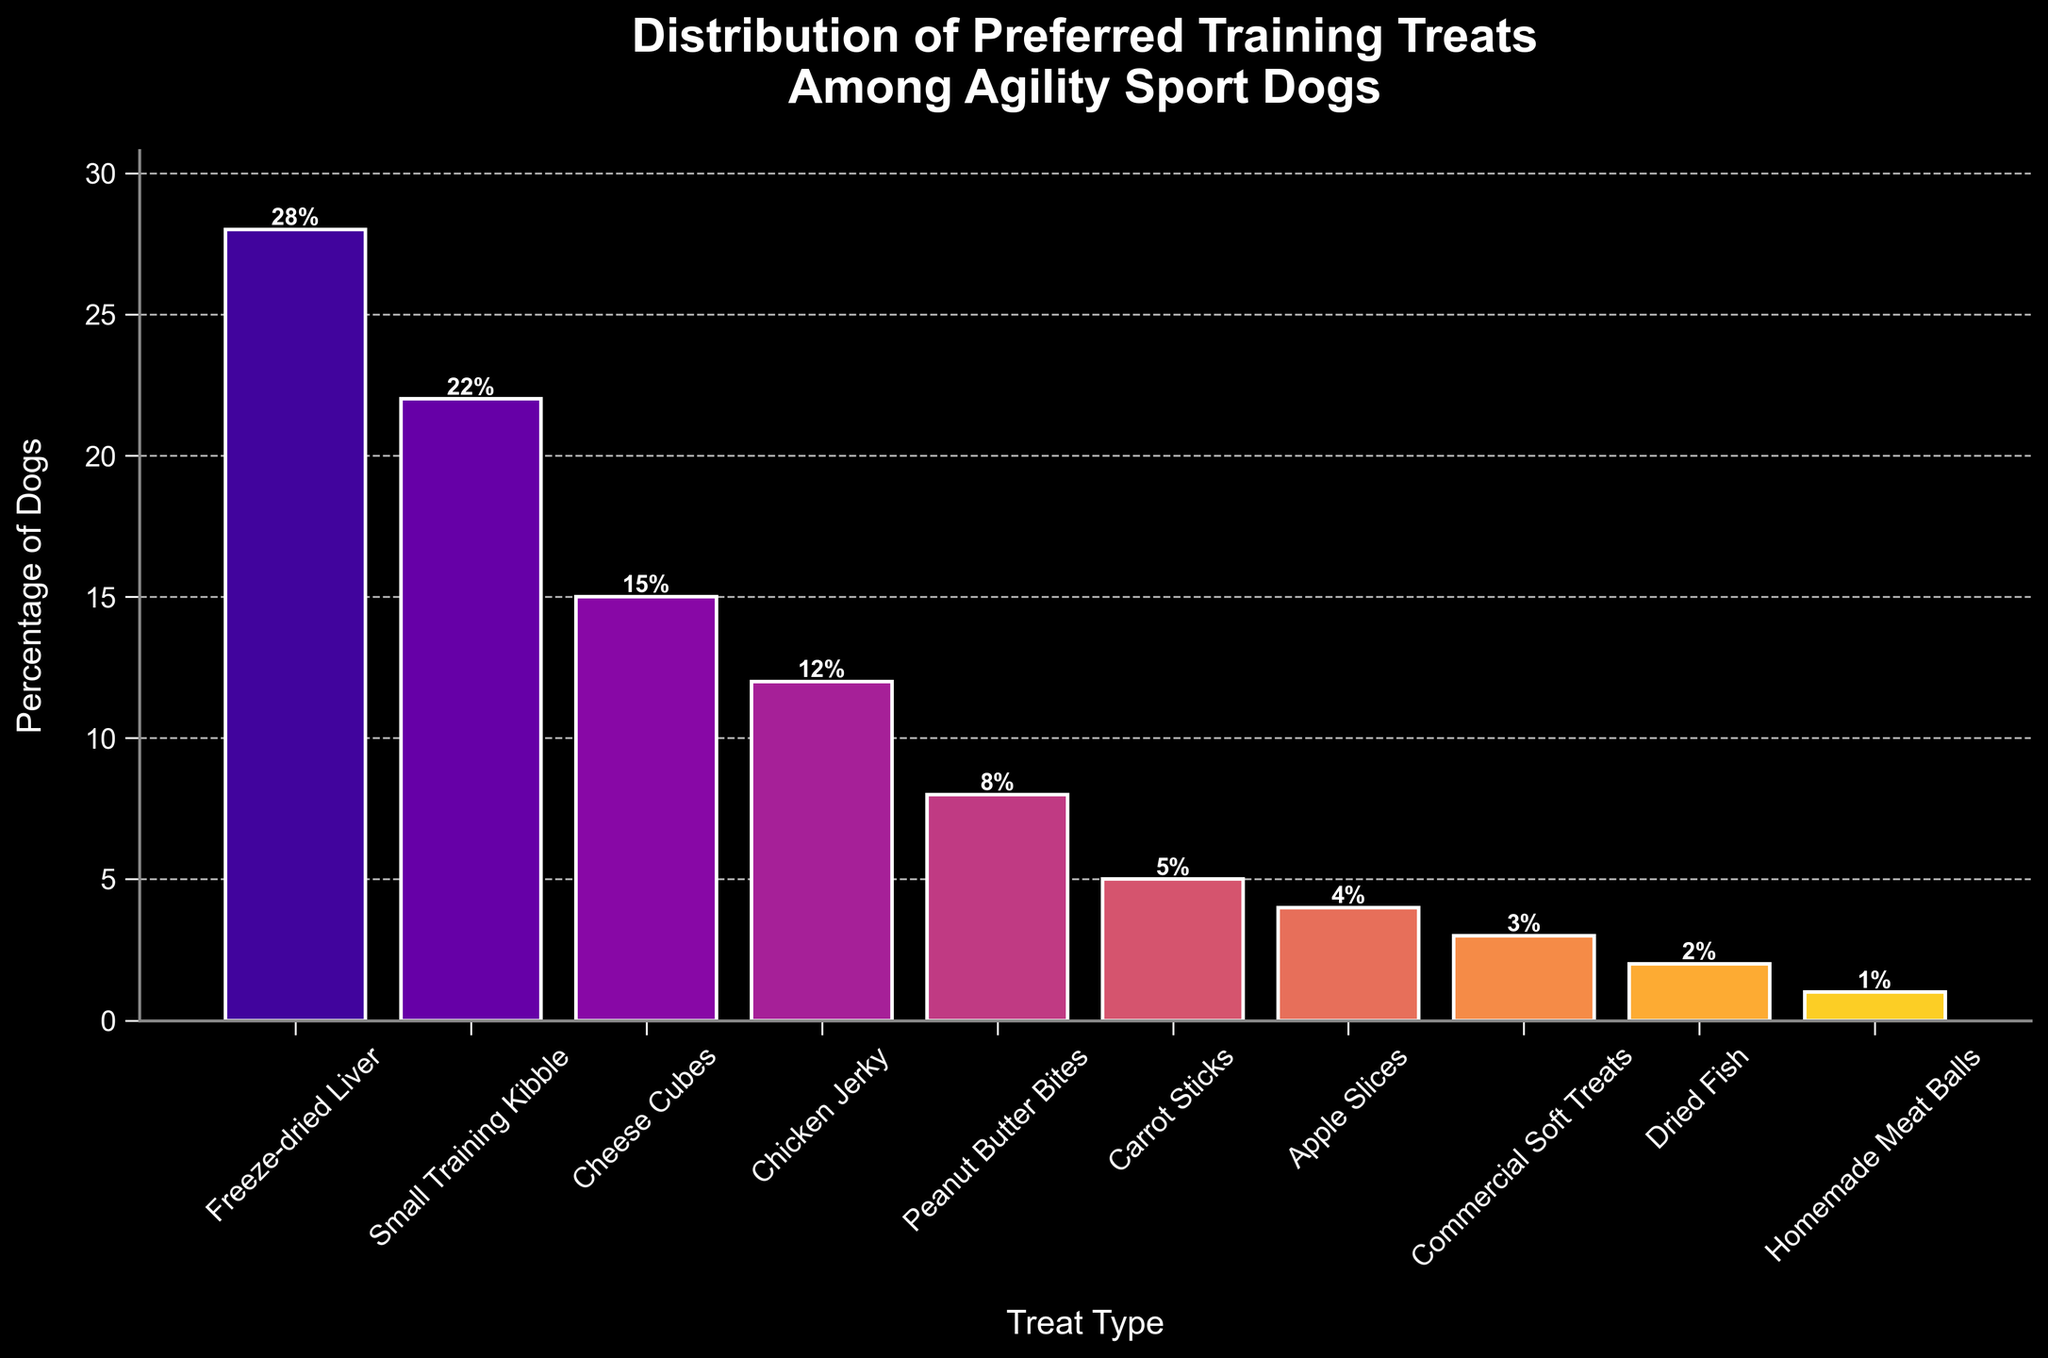What treat is most preferred by agility sport dogs? Look at the highest bar on the chart to find the treat type associated with the highest percentage. The tallest bar represents Freeze-dried Liver with 28%.
Answer: Freeze-dried Liver Which treat type is preferred by less than 10% of dogs? Check bars whose heights are less than 10% on the y-axis. These include Peanut Butter Bites, Carrot Sticks, Apple Slices, Commercial Soft Treats, Dried Fish, and Homemade Meat Balls.
Answer: Peanut Butter Bites, Carrot Sticks, Apple Slices, Commercial Soft Treats, Dried Fish, Homemade Meat Balls What is the total percentage of dogs that prefer Cheese Cubes and Chicken Jerky combined? Add the percentage of dogs that prefer Cheese Cubes (15%) to those that prefer Chicken Jerky (12%). 15% + 12% = 27%
Answer: 27% Which treat type has a lower preference percentage, Carrot Sticks or Apple Slices? Compare the heights of the bars for Carrot Sticks and Apple Slices. Carrot Sticks is at 5% while Apple Slices is at 4%. Therefore, Apple Slices has a lower preference.
Answer: Apple Slices Is the percentage of dogs that prefer Dried Fish higher than that of dogs that prefer Homemade Meat Balls? Compare the bar heights for Dried Fish (2%) and Homemade Meat Balls (1%). Dried Fish has a higher percentage.
Answer: Yes What is the difference in percentage between the most and least preferred treats? Subtract the percentage of the least preferred treat (Homemade Meat Balls, 1%) from the most preferred treat (Freeze-dried Liver, 28%). 28% - 1% = 27%
Answer: 27% Which treat type has a higher preference, Chicken Jerky or Peanut Butter Bites? Compare the heights of the bars for Chicken Jerky and Peanut Butter Bites. Chicken Jerky is at 12%, while Peanut Butter Bites is at 8%. Therefore, Chicken Jerky has a higher preference.
Answer: Chicken Jerky What is the average percentage preference for the top three preferred treats? The top three preferred treats are Freeze-dried Liver (28%), Small Training Kibble (22%), and Cheese Cubes (15%). Add these percentages and divide by 3 to find the average: (28% + 22% + 15%) / 3 = 21.67%
Answer: 21.67% What is the sum of the percentages of dogs that prefer the four least preferred treats? The four least preferred treats are Apple Slices (4%), Commercial Soft Treats (3%), Dried Fish (2%), and Homemade Meat Balls (1%). Sum these percentages: 4% + 3% + 2% + 1% = 10%
Answer: 10% How many treat types have a preference percentage between 5% and 15%? Identify treat types with preference percentages within the given range: Cheese Cubes (15%), Chicken Jerky (12%), Peanut Butter Bites (8%), and Carrot Sticks (5%)—there are four such treat types.
Answer: 4 